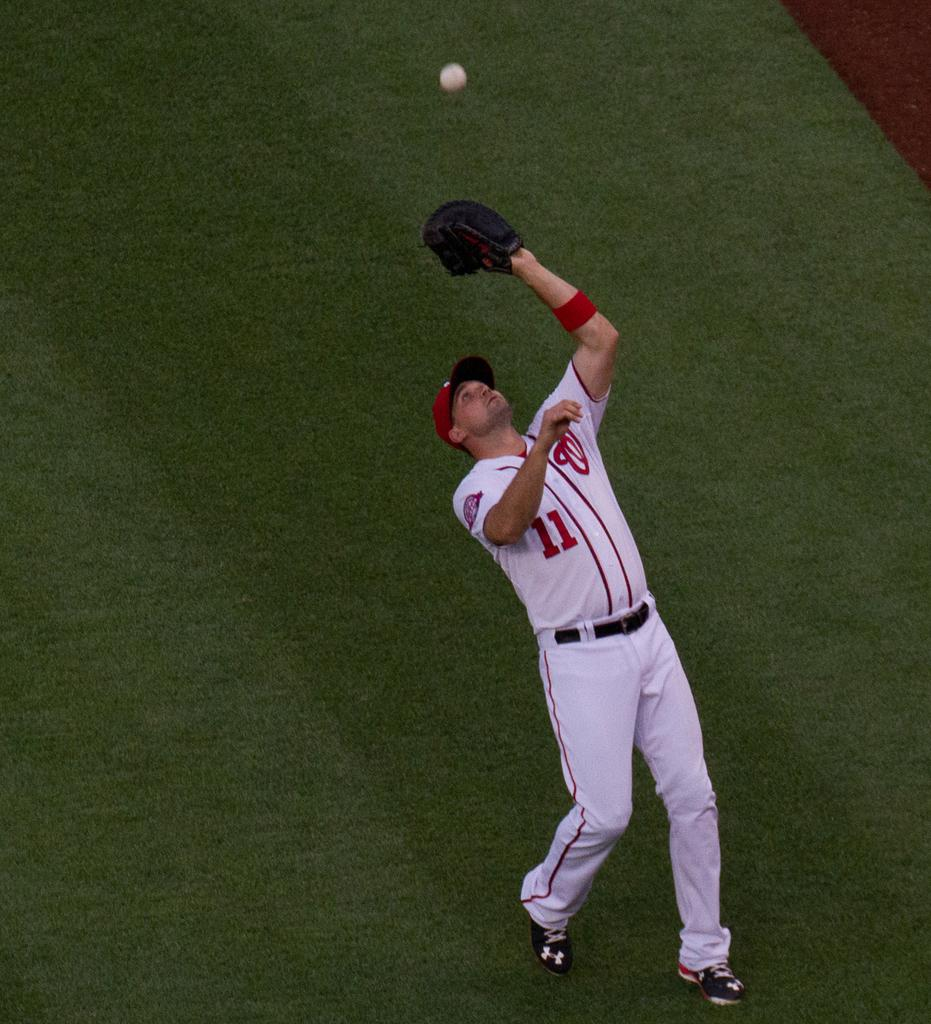<image>
Summarize the visual content of the image. Baseball player wearing number 11 on his jersey. 